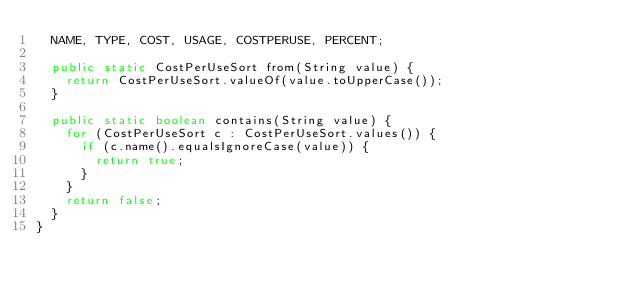Convert code to text. <code><loc_0><loc_0><loc_500><loc_500><_Java_>  NAME, TYPE, COST, USAGE, COSTPERUSE, PERCENT;

  public static CostPerUseSort from(String value) {
    return CostPerUseSort.valueOf(value.toUpperCase());
  }

  public static boolean contains(String value) {
    for (CostPerUseSort c : CostPerUseSort.values()) {
      if (c.name().equalsIgnoreCase(value)) {
        return true;
      }
    }
    return false;
  }
}</code> 